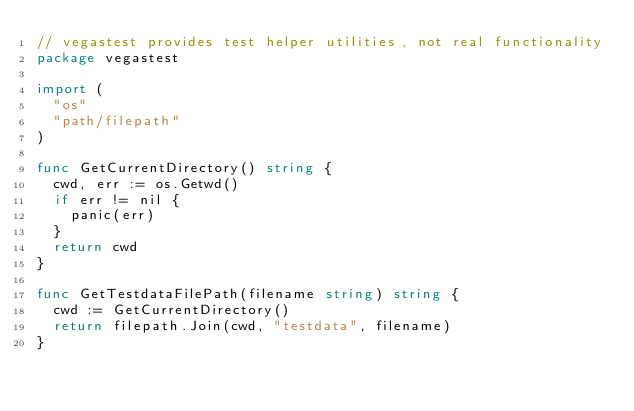Convert code to text. <code><loc_0><loc_0><loc_500><loc_500><_Go_>// vegastest provides test helper utilities, not real functionality
package vegastest

import (
	"os"
	"path/filepath"
)

func GetCurrentDirectory() string {
	cwd, err := os.Getwd()
	if err != nil {
		panic(err)
	}
	return cwd
}

func GetTestdataFilePath(filename string) string {
	cwd := GetCurrentDirectory()
	return filepath.Join(cwd, "testdata", filename)
}
</code> 